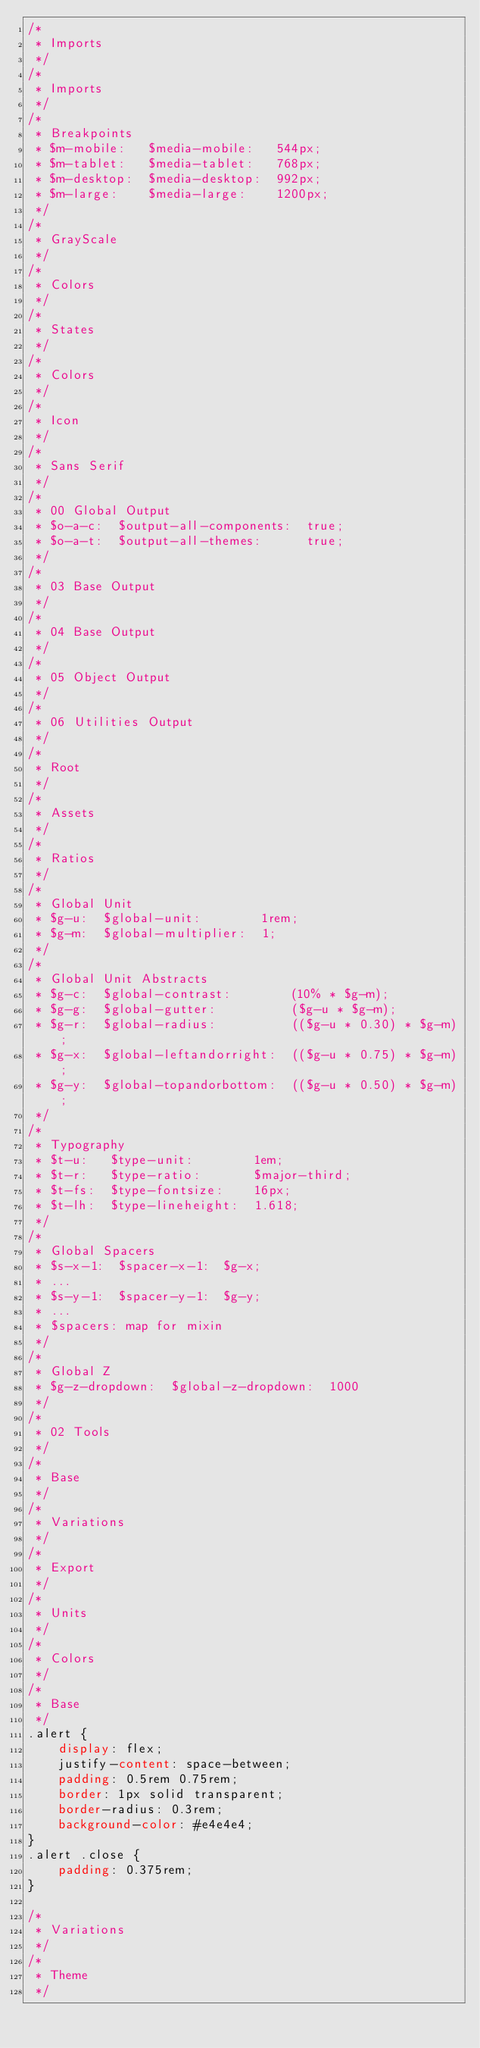Convert code to text. <code><loc_0><loc_0><loc_500><loc_500><_CSS_>/*
 * Imports
 */
/*
 * Imports
 */
/*
 * Breakpoints
 * $m-mobile:   $media-mobile:   544px;
 * $m-tablet:   $media-tablet:   768px;
 * $m-desktop:  $media-desktop:  992px;
 * $m-large:    $media-large:    1200px;
 */
/*
 * GrayScale
 */
/*
 * Colors
 */
/*
 * States
 */
/*
 * Colors
 */
/*
 * Icon
 */
/*
 * Sans Serif
 */
/*
 * 00 Global Output
 * $o-a-c:  $output-all-components:  true;
 * $o-a-t:  $output-all-themes:      true;
 */
/*
 * 03 Base Output
 */
/*
 * 04 Base Output
 */
/*
 * 05 Object Output
 */
/*
 * 06 Utilities Output
 */
/*
 * Root
 */
/*
 * Assets
 */
/*
 * Ratios
 */
/*
 * Global Unit
 * $g-u:  $global-unit:        1rem;
 * $g-m:  $global-multiplier:  1;
 */
/*
 * Global Unit Abstracts
 * $g-c:  $global-contrast:        (10% * $g-m);
 * $g-g:  $global-gutter:          ($g-u * $g-m);
 * $g-r:  $global-radius:          (($g-u * 0.30) * $g-m);
 * $g-x:  $global-leftandorright:  (($g-u * 0.75) * $g-m);
 * $g-y:  $global-topandorbottom:  (($g-u * 0.50) * $g-m);
 */
/*
 * Typography
 * $t-u:   $type-unit:        1em;
 * $t-r:   $type-ratio:       $major-third;
 * $t-fs:  $type-fontsize:    16px;
 * $t-lh:  $type-lineheight:  1.618;
 */
/*
 * Global Spacers
 * $s-x-1:  $spacer-x-1:  $g-x;
 * ...
 * $s-y-1:  $spacer-y-1:  $g-y;
 * ...
 * $spacers: map for mixin
 */
/*
 * Global Z
 * $g-z-dropdown:  $global-z-dropdown:  1000
 */
/*
 * 02 Tools
 */
/*
 * Base
 */
/*
 * Variations
 */
/*
 * Export
 */
/*
 * Units
 */
/*
 * Colors
 */
/*
 * Base
 */
.alert {
    display: flex;
    justify-content: space-between;
    padding: 0.5rem 0.75rem;
    border: 1px solid transparent;
    border-radius: 0.3rem;
    background-color: #e4e4e4;
}
.alert .close {
    padding: 0.375rem;
}

/*
 * Variations
 */
/*
 * Theme
 */
</code> 